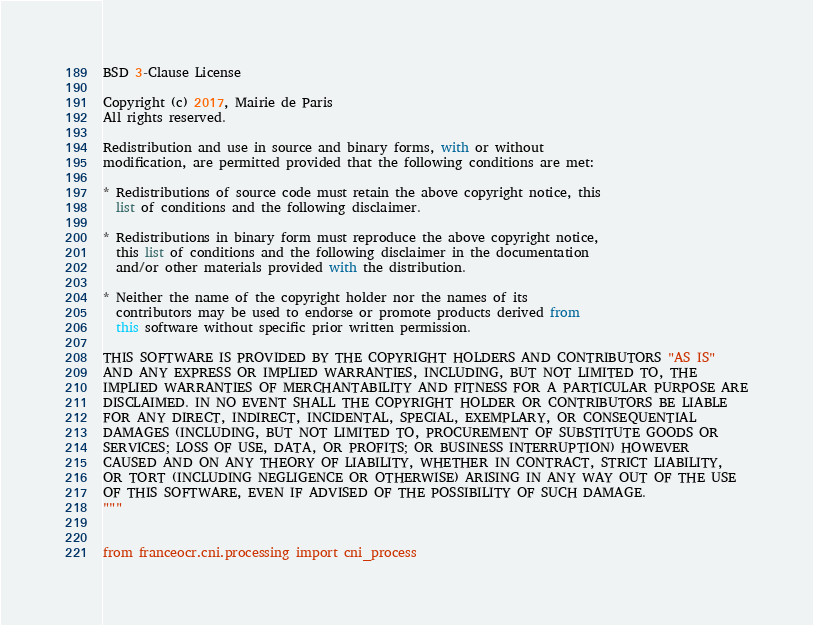<code> <loc_0><loc_0><loc_500><loc_500><_Python_>BSD 3-Clause License

Copyright (c) 2017, Mairie de Paris
All rights reserved.

Redistribution and use in source and binary forms, with or without
modification, are permitted provided that the following conditions are met:

* Redistributions of source code must retain the above copyright notice, this
  list of conditions and the following disclaimer.

* Redistributions in binary form must reproduce the above copyright notice,
  this list of conditions and the following disclaimer in the documentation
  and/or other materials provided with the distribution.

* Neither the name of the copyright holder nor the names of its
  contributors may be used to endorse or promote products derived from
  this software without specific prior written permission.

THIS SOFTWARE IS PROVIDED BY THE COPYRIGHT HOLDERS AND CONTRIBUTORS "AS IS"
AND ANY EXPRESS OR IMPLIED WARRANTIES, INCLUDING, BUT NOT LIMITED TO, THE
IMPLIED WARRANTIES OF MERCHANTABILITY AND FITNESS FOR A PARTICULAR PURPOSE ARE
DISCLAIMED. IN NO EVENT SHALL THE COPYRIGHT HOLDER OR CONTRIBUTORS BE LIABLE
FOR ANY DIRECT, INDIRECT, INCIDENTAL, SPECIAL, EXEMPLARY, OR CONSEQUENTIAL
DAMAGES (INCLUDING, BUT NOT LIMITED TO, PROCUREMENT OF SUBSTITUTE GOODS OR
SERVICES; LOSS OF USE, DATA, OR PROFITS; OR BUSINESS INTERRUPTION) HOWEVER
CAUSED AND ON ANY THEORY OF LIABILITY, WHETHER IN CONTRACT, STRICT LIABILITY,
OR TORT (INCLUDING NEGLIGENCE OR OTHERWISE) ARISING IN ANY WAY OUT OF THE USE
OF THIS SOFTWARE, EVEN IF ADVISED OF THE POSSIBILITY OF SUCH DAMAGE.
"""


from franceocr.cni.processing import cni_process
</code> 